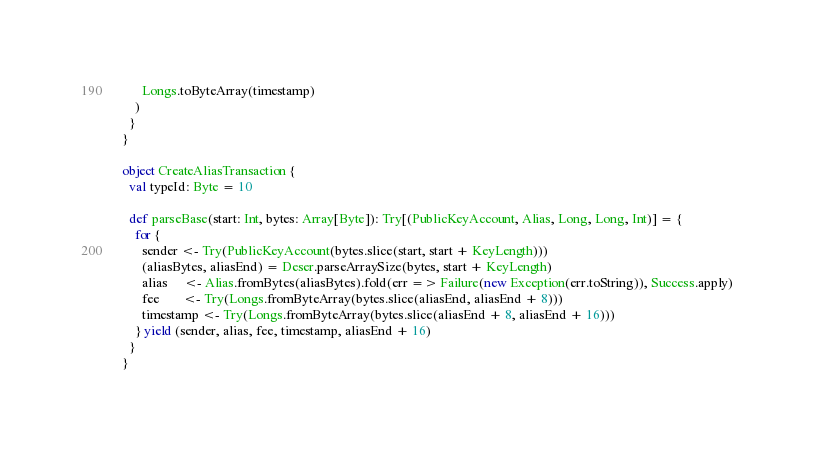Convert code to text. <code><loc_0><loc_0><loc_500><loc_500><_Scala_>      Longs.toByteArray(timestamp)
    )
  }
}

object CreateAliasTransaction {
  val typeId: Byte = 10

  def parseBase(start: Int, bytes: Array[Byte]): Try[(PublicKeyAccount, Alias, Long, Long, Int)] = {
    for {
      sender <- Try(PublicKeyAccount(bytes.slice(start, start + KeyLength)))
      (aliasBytes, aliasEnd) = Deser.parseArraySize(bytes, start + KeyLength)
      alias     <- Alias.fromBytes(aliasBytes).fold(err => Failure(new Exception(err.toString)), Success.apply)
      fee       <- Try(Longs.fromByteArray(bytes.slice(aliasEnd, aliasEnd + 8)))
      timestamp <- Try(Longs.fromByteArray(bytes.slice(aliasEnd + 8, aliasEnd + 16)))
    } yield (sender, alias, fee, timestamp, aliasEnd + 16)
  }
}
</code> 